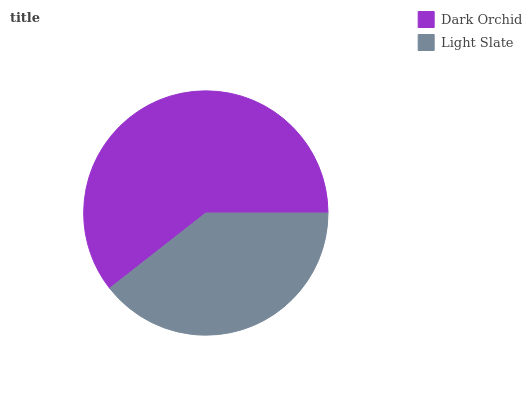Is Light Slate the minimum?
Answer yes or no. Yes. Is Dark Orchid the maximum?
Answer yes or no. Yes. Is Light Slate the maximum?
Answer yes or no. No. Is Dark Orchid greater than Light Slate?
Answer yes or no. Yes. Is Light Slate less than Dark Orchid?
Answer yes or no. Yes. Is Light Slate greater than Dark Orchid?
Answer yes or no. No. Is Dark Orchid less than Light Slate?
Answer yes or no. No. Is Dark Orchid the high median?
Answer yes or no. Yes. Is Light Slate the low median?
Answer yes or no. Yes. Is Light Slate the high median?
Answer yes or no. No. Is Dark Orchid the low median?
Answer yes or no. No. 